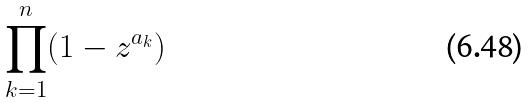Convert formula to latex. <formula><loc_0><loc_0><loc_500><loc_500>\prod _ { k = 1 } ^ { n } ( 1 - z ^ { a _ { k } } )</formula> 